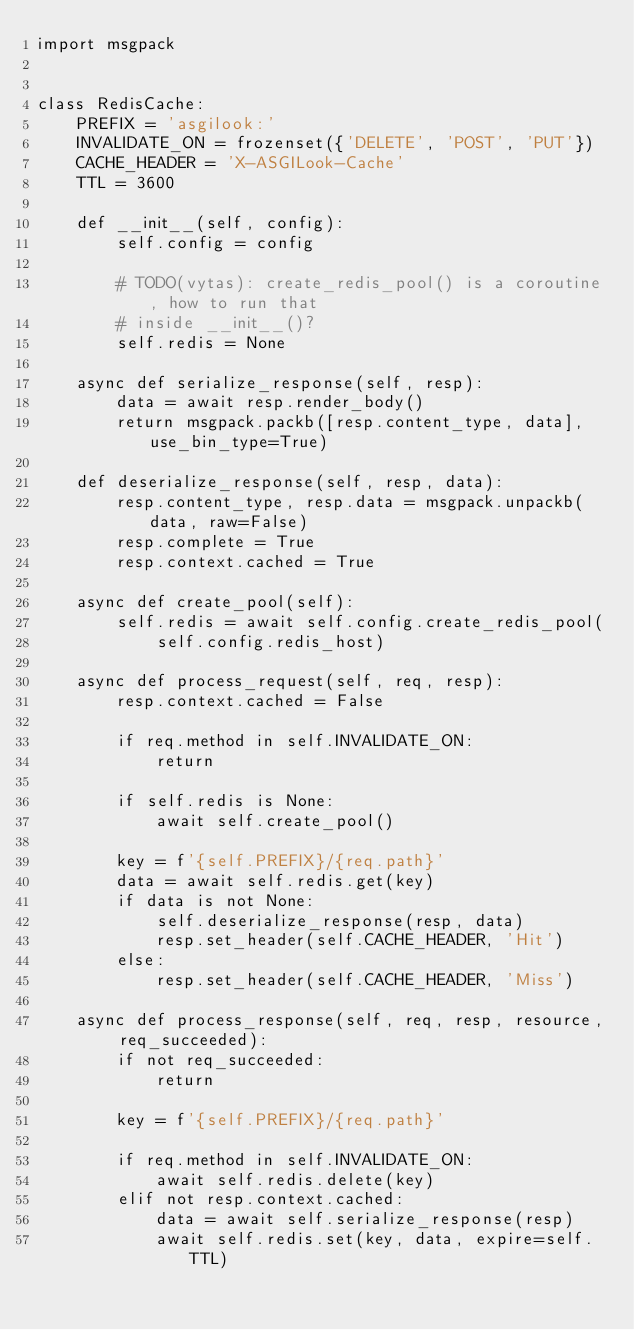Convert code to text. <code><loc_0><loc_0><loc_500><loc_500><_Python_>import msgpack


class RedisCache:
    PREFIX = 'asgilook:'
    INVALIDATE_ON = frozenset({'DELETE', 'POST', 'PUT'})
    CACHE_HEADER = 'X-ASGILook-Cache'
    TTL = 3600

    def __init__(self, config):
        self.config = config

        # TODO(vytas): create_redis_pool() is a coroutine, how to run that
        # inside __init__()?
        self.redis = None

    async def serialize_response(self, resp):
        data = await resp.render_body()
        return msgpack.packb([resp.content_type, data], use_bin_type=True)

    def deserialize_response(self, resp, data):
        resp.content_type, resp.data = msgpack.unpackb(data, raw=False)
        resp.complete = True
        resp.context.cached = True

    async def create_pool(self):
        self.redis = await self.config.create_redis_pool(
            self.config.redis_host)

    async def process_request(self, req, resp):
        resp.context.cached = False

        if req.method in self.INVALIDATE_ON:
            return

        if self.redis is None:
            await self.create_pool()

        key = f'{self.PREFIX}/{req.path}'
        data = await self.redis.get(key)
        if data is not None:
            self.deserialize_response(resp, data)
            resp.set_header(self.CACHE_HEADER, 'Hit')
        else:
            resp.set_header(self.CACHE_HEADER, 'Miss')

    async def process_response(self, req, resp, resource, req_succeeded):
        if not req_succeeded:
            return

        key = f'{self.PREFIX}/{req.path}'

        if req.method in self.INVALIDATE_ON:
            await self.redis.delete(key)
        elif not resp.context.cached:
            data = await self.serialize_response(resp)
            await self.redis.set(key, data, expire=self.TTL)
</code> 